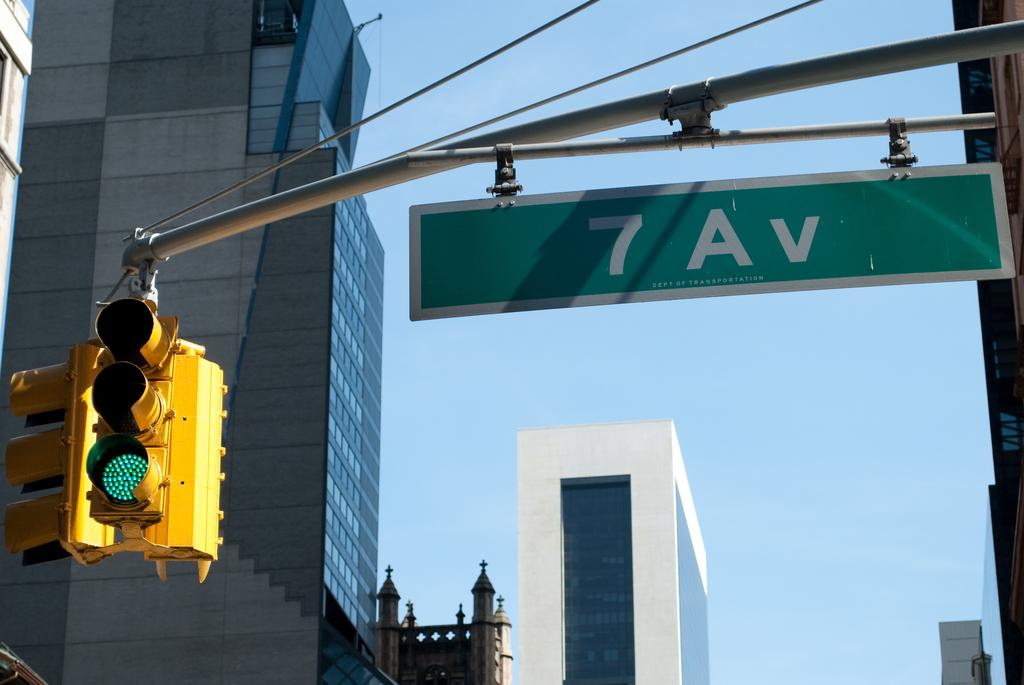Provide a one-sentence caption for the provided image. A sign that has 7 Av on it in green. 